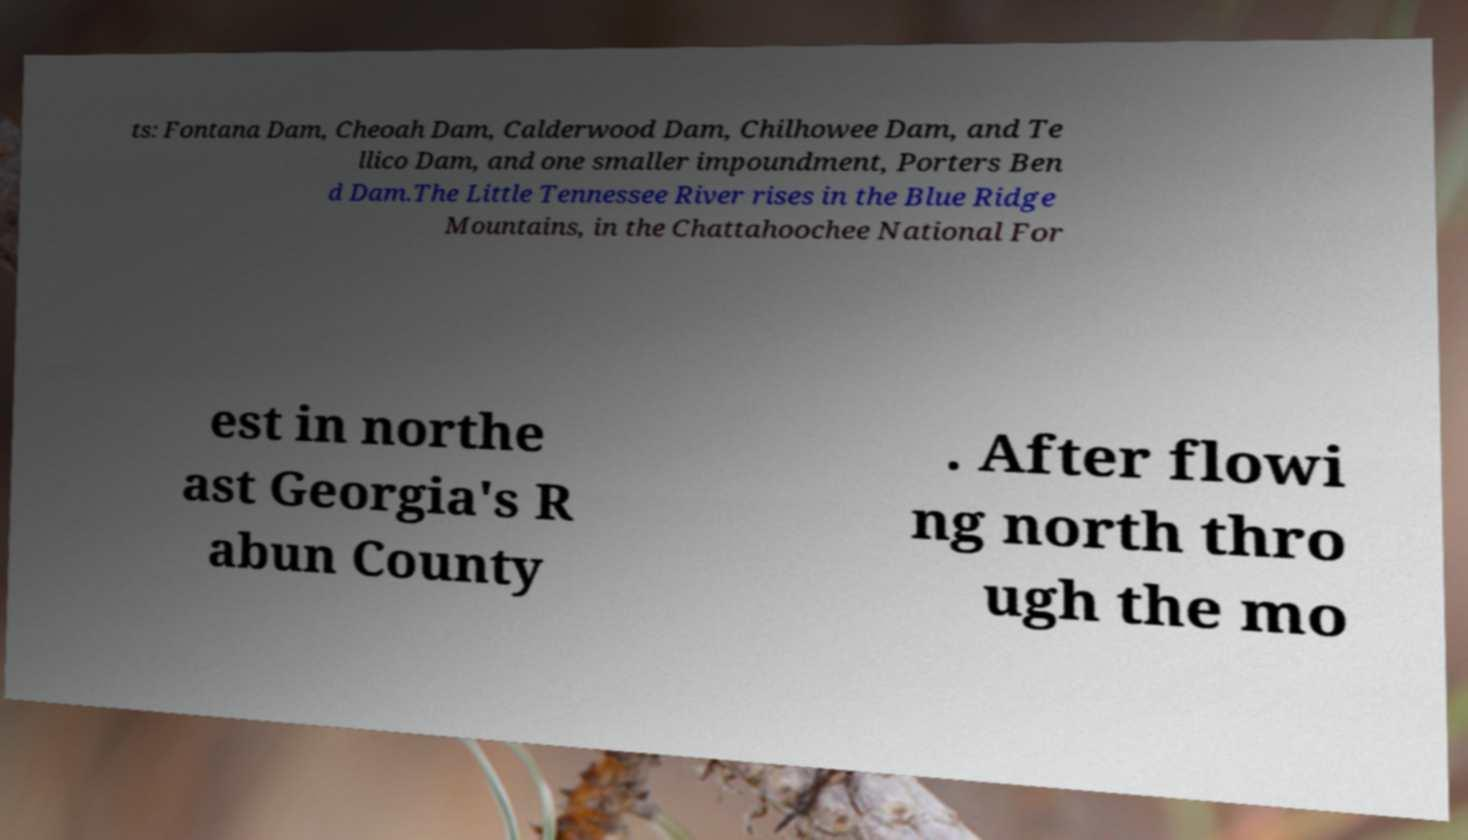Please identify and transcribe the text found in this image. ts: Fontana Dam, Cheoah Dam, Calderwood Dam, Chilhowee Dam, and Te llico Dam, and one smaller impoundment, Porters Ben d Dam.The Little Tennessee River rises in the Blue Ridge Mountains, in the Chattahoochee National For est in northe ast Georgia's R abun County . After flowi ng north thro ugh the mo 